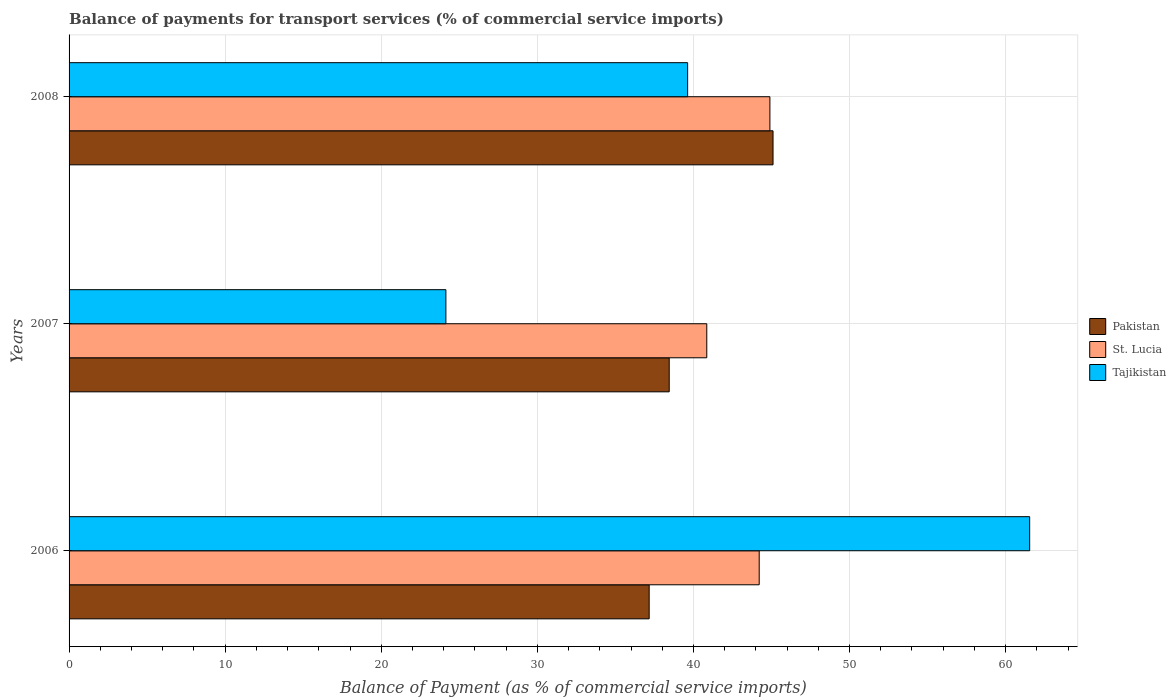Are the number of bars per tick equal to the number of legend labels?
Your answer should be compact. Yes. How many bars are there on the 2nd tick from the top?
Provide a succinct answer. 3. How many bars are there on the 3rd tick from the bottom?
Offer a terse response. 3. What is the label of the 2nd group of bars from the top?
Give a very brief answer. 2007. In how many cases, is the number of bars for a given year not equal to the number of legend labels?
Offer a very short reply. 0. What is the balance of payments for transport services in Tajikistan in 2007?
Offer a very short reply. 24.14. Across all years, what is the maximum balance of payments for transport services in St. Lucia?
Make the answer very short. 44.9. Across all years, what is the minimum balance of payments for transport services in St. Lucia?
Keep it short and to the point. 40.85. In which year was the balance of payments for transport services in Pakistan maximum?
Provide a succinct answer. 2008. In which year was the balance of payments for transport services in St. Lucia minimum?
Make the answer very short. 2007. What is the total balance of payments for transport services in St. Lucia in the graph?
Offer a very short reply. 129.96. What is the difference between the balance of payments for transport services in St. Lucia in 2006 and that in 2008?
Ensure brevity in your answer.  -0.69. What is the difference between the balance of payments for transport services in St. Lucia in 2006 and the balance of payments for transport services in Pakistan in 2007?
Your answer should be compact. 5.76. What is the average balance of payments for transport services in Tajikistan per year?
Your answer should be compact. 41.77. In the year 2006, what is the difference between the balance of payments for transport services in Tajikistan and balance of payments for transport services in Pakistan?
Make the answer very short. 24.38. What is the ratio of the balance of payments for transport services in Pakistan in 2006 to that in 2008?
Offer a terse response. 0.82. Is the balance of payments for transport services in Tajikistan in 2007 less than that in 2008?
Offer a very short reply. Yes. Is the difference between the balance of payments for transport services in Tajikistan in 2007 and 2008 greater than the difference between the balance of payments for transport services in Pakistan in 2007 and 2008?
Offer a very short reply. No. What is the difference between the highest and the second highest balance of payments for transport services in Tajikistan?
Your response must be concise. 21.91. What is the difference between the highest and the lowest balance of payments for transport services in St. Lucia?
Provide a short and direct response. 4.04. In how many years, is the balance of payments for transport services in Pakistan greater than the average balance of payments for transport services in Pakistan taken over all years?
Your answer should be very brief. 1. What does the 3rd bar from the top in 2008 represents?
Ensure brevity in your answer.  Pakistan. Are all the bars in the graph horizontal?
Ensure brevity in your answer.  Yes. How many years are there in the graph?
Make the answer very short. 3. Does the graph contain any zero values?
Your answer should be very brief. No. Does the graph contain grids?
Provide a succinct answer. Yes. Where does the legend appear in the graph?
Ensure brevity in your answer.  Center right. How many legend labels are there?
Your answer should be compact. 3. How are the legend labels stacked?
Keep it short and to the point. Vertical. What is the title of the graph?
Keep it short and to the point. Balance of payments for transport services (% of commercial service imports). What is the label or title of the X-axis?
Your response must be concise. Balance of Payment (as % of commercial service imports). What is the label or title of the Y-axis?
Your answer should be compact. Years. What is the Balance of Payment (as % of commercial service imports) in Pakistan in 2006?
Your answer should be compact. 37.16. What is the Balance of Payment (as % of commercial service imports) in St. Lucia in 2006?
Your response must be concise. 44.21. What is the Balance of Payment (as % of commercial service imports) of Tajikistan in 2006?
Provide a succinct answer. 61.54. What is the Balance of Payment (as % of commercial service imports) in Pakistan in 2007?
Offer a terse response. 38.45. What is the Balance of Payment (as % of commercial service imports) in St. Lucia in 2007?
Provide a short and direct response. 40.85. What is the Balance of Payment (as % of commercial service imports) of Tajikistan in 2007?
Keep it short and to the point. 24.14. What is the Balance of Payment (as % of commercial service imports) in Pakistan in 2008?
Offer a terse response. 45.1. What is the Balance of Payment (as % of commercial service imports) in St. Lucia in 2008?
Make the answer very short. 44.9. What is the Balance of Payment (as % of commercial service imports) in Tajikistan in 2008?
Give a very brief answer. 39.63. Across all years, what is the maximum Balance of Payment (as % of commercial service imports) in Pakistan?
Your answer should be very brief. 45.1. Across all years, what is the maximum Balance of Payment (as % of commercial service imports) in St. Lucia?
Offer a very short reply. 44.9. Across all years, what is the maximum Balance of Payment (as % of commercial service imports) of Tajikistan?
Your response must be concise. 61.54. Across all years, what is the minimum Balance of Payment (as % of commercial service imports) of Pakistan?
Ensure brevity in your answer.  37.16. Across all years, what is the minimum Balance of Payment (as % of commercial service imports) in St. Lucia?
Give a very brief answer. 40.85. Across all years, what is the minimum Balance of Payment (as % of commercial service imports) in Tajikistan?
Make the answer very short. 24.14. What is the total Balance of Payment (as % of commercial service imports) in Pakistan in the graph?
Offer a terse response. 120.71. What is the total Balance of Payment (as % of commercial service imports) of St. Lucia in the graph?
Your answer should be compact. 129.96. What is the total Balance of Payment (as % of commercial service imports) of Tajikistan in the graph?
Your response must be concise. 125.31. What is the difference between the Balance of Payment (as % of commercial service imports) in Pakistan in 2006 and that in 2007?
Ensure brevity in your answer.  -1.28. What is the difference between the Balance of Payment (as % of commercial service imports) of St. Lucia in 2006 and that in 2007?
Keep it short and to the point. 3.36. What is the difference between the Balance of Payment (as % of commercial service imports) in Tajikistan in 2006 and that in 2007?
Offer a very short reply. 37.4. What is the difference between the Balance of Payment (as % of commercial service imports) of Pakistan in 2006 and that in 2008?
Offer a terse response. -7.94. What is the difference between the Balance of Payment (as % of commercial service imports) of St. Lucia in 2006 and that in 2008?
Your answer should be compact. -0.69. What is the difference between the Balance of Payment (as % of commercial service imports) of Tajikistan in 2006 and that in 2008?
Your answer should be very brief. 21.91. What is the difference between the Balance of Payment (as % of commercial service imports) in Pakistan in 2007 and that in 2008?
Provide a short and direct response. -6.65. What is the difference between the Balance of Payment (as % of commercial service imports) in St. Lucia in 2007 and that in 2008?
Your answer should be compact. -4.04. What is the difference between the Balance of Payment (as % of commercial service imports) of Tajikistan in 2007 and that in 2008?
Provide a short and direct response. -15.49. What is the difference between the Balance of Payment (as % of commercial service imports) in Pakistan in 2006 and the Balance of Payment (as % of commercial service imports) in St. Lucia in 2007?
Your answer should be compact. -3.69. What is the difference between the Balance of Payment (as % of commercial service imports) of Pakistan in 2006 and the Balance of Payment (as % of commercial service imports) of Tajikistan in 2007?
Keep it short and to the point. 13.02. What is the difference between the Balance of Payment (as % of commercial service imports) of St. Lucia in 2006 and the Balance of Payment (as % of commercial service imports) of Tajikistan in 2007?
Give a very brief answer. 20.07. What is the difference between the Balance of Payment (as % of commercial service imports) in Pakistan in 2006 and the Balance of Payment (as % of commercial service imports) in St. Lucia in 2008?
Make the answer very short. -7.73. What is the difference between the Balance of Payment (as % of commercial service imports) of Pakistan in 2006 and the Balance of Payment (as % of commercial service imports) of Tajikistan in 2008?
Provide a succinct answer. -2.46. What is the difference between the Balance of Payment (as % of commercial service imports) of St. Lucia in 2006 and the Balance of Payment (as % of commercial service imports) of Tajikistan in 2008?
Give a very brief answer. 4.59. What is the difference between the Balance of Payment (as % of commercial service imports) of Pakistan in 2007 and the Balance of Payment (as % of commercial service imports) of St. Lucia in 2008?
Your answer should be very brief. -6.45. What is the difference between the Balance of Payment (as % of commercial service imports) in Pakistan in 2007 and the Balance of Payment (as % of commercial service imports) in Tajikistan in 2008?
Offer a very short reply. -1.18. What is the difference between the Balance of Payment (as % of commercial service imports) of St. Lucia in 2007 and the Balance of Payment (as % of commercial service imports) of Tajikistan in 2008?
Your answer should be compact. 1.23. What is the average Balance of Payment (as % of commercial service imports) in Pakistan per year?
Ensure brevity in your answer.  40.24. What is the average Balance of Payment (as % of commercial service imports) in St. Lucia per year?
Give a very brief answer. 43.32. What is the average Balance of Payment (as % of commercial service imports) in Tajikistan per year?
Your answer should be very brief. 41.77. In the year 2006, what is the difference between the Balance of Payment (as % of commercial service imports) in Pakistan and Balance of Payment (as % of commercial service imports) in St. Lucia?
Offer a very short reply. -7.05. In the year 2006, what is the difference between the Balance of Payment (as % of commercial service imports) in Pakistan and Balance of Payment (as % of commercial service imports) in Tajikistan?
Make the answer very short. -24.38. In the year 2006, what is the difference between the Balance of Payment (as % of commercial service imports) in St. Lucia and Balance of Payment (as % of commercial service imports) in Tajikistan?
Provide a short and direct response. -17.33. In the year 2007, what is the difference between the Balance of Payment (as % of commercial service imports) of Pakistan and Balance of Payment (as % of commercial service imports) of St. Lucia?
Keep it short and to the point. -2.41. In the year 2007, what is the difference between the Balance of Payment (as % of commercial service imports) in Pakistan and Balance of Payment (as % of commercial service imports) in Tajikistan?
Make the answer very short. 14.31. In the year 2007, what is the difference between the Balance of Payment (as % of commercial service imports) of St. Lucia and Balance of Payment (as % of commercial service imports) of Tajikistan?
Make the answer very short. 16.71. In the year 2008, what is the difference between the Balance of Payment (as % of commercial service imports) in Pakistan and Balance of Payment (as % of commercial service imports) in St. Lucia?
Give a very brief answer. 0.2. In the year 2008, what is the difference between the Balance of Payment (as % of commercial service imports) in Pakistan and Balance of Payment (as % of commercial service imports) in Tajikistan?
Offer a terse response. 5.47. In the year 2008, what is the difference between the Balance of Payment (as % of commercial service imports) of St. Lucia and Balance of Payment (as % of commercial service imports) of Tajikistan?
Provide a succinct answer. 5.27. What is the ratio of the Balance of Payment (as % of commercial service imports) in Pakistan in 2006 to that in 2007?
Provide a succinct answer. 0.97. What is the ratio of the Balance of Payment (as % of commercial service imports) in St. Lucia in 2006 to that in 2007?
Provide a short and direct response. 1.08. What is the ratio of the Balance of Payment (as % of commercial service imports) in Tajikistan in 2006 to that in 2007?
Provide a short and direct response. 2.55. What is the ratio of the Balance of Payment (as % of commercial service imports) in Pakistan in 2006 to that in 2008?
Keep it short and to the point. 0.82. What is the ratio of the Balance of Payment (as % of commercial service imports) in St. Lucia in 2006 to that in 2008?
Your response must be concise. 0.98. What is the ratio of the Balance of Payment (as % of commercial service imports) of Tajikistan in 2006 to that in 2008?
Provide a short and direct response. 1.55. What is the ratio of the Balance of Payment (as % of commercial service imports) of Pakistan in 2007 to that in 2008?
Ensure brevity in your answer.  0.85. What is the ratio of the Balance of Payment (as % of commercial service imports) in St. Lucia in 2007 to that in 2008?
Offer a terse response. 0.91. What is the ratio of the Balance of Payment (as % of commercial service imports) in Tajikistan in 2007 to that in 2008?
Provide a succinct answer. 0.61. What is the difference between the highest and the second highest Balance of Payment (as % of commercial service imports) in Pakistan?
Make the answer very short. 6.65. What is the difference between the highest and the second highest Balance of Payment (as % of commercial service imports) of St. Lucia?
Your response must be concise. 0.69. What is the difference between the highest and the second highest Balance of Payment (as % of commercial service imports) of Tajikistan?
Your answer should be compact. 21.91. What is the difference between the highest and the lowest Balance of Payment (as % of commercial service imports) of Pakistan?
Offer a terse response. 7.94. What is the difference between the highest and the lowest Balance of Payment (as % of commercial service imports) of St. Lucia?
Keep it short and to the point. 4.04. What is the difference between the highest and the lowest Balance of Payment (as % of commercial service imports) of Tajikistan?
Your answer should be very brief. 37.4. 